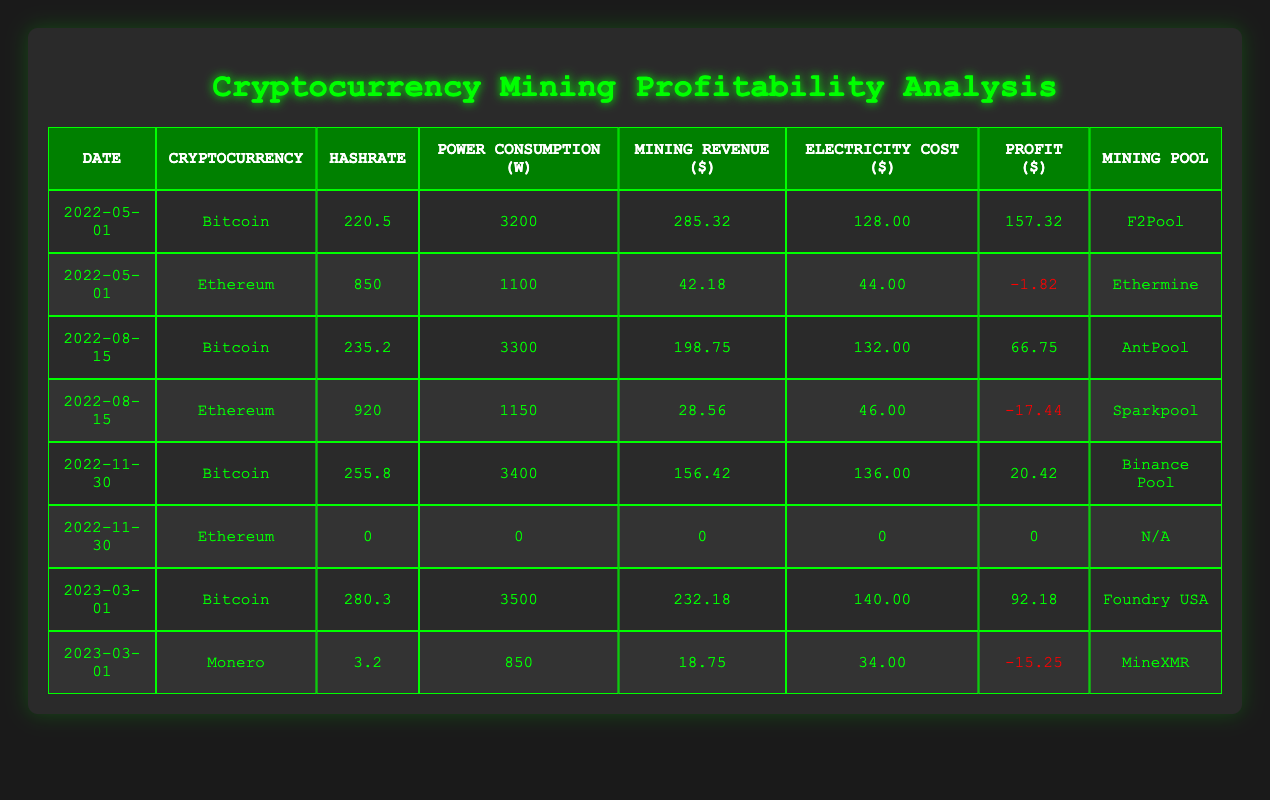What is the profit for Bitcoin on May 1, 2022? The profit for Bitcoin on May 1, 2022, is located directly in the table under the profit column in the corresponding row. It shows a profit of 157.32.
Answer: 157.32 What was the electricity cost for mining Ethereum on August 15, 2022? To find the electricity cost of Ethereum on August 15, 2022, check the row for Ethereum on that date, where the electricity cost is specified as 46.00.
Answer: 46.00 Which cryptocurrency had the highest profit on March 1, 2023? To determine the highest profit on March 1, 2023, compare the profit values from the table for all cryptocurrencies listed on that date. Bitcoin has a profit of 92.18, while Monero has a profit of -15.25. Bitcoin has the highest profit.
Answer: Bitcoin What is the average mining revenue for Bitcoin across all the recorded dates? First, gather the mining revenue values for Bitcoin from each row: 285.32, 198.75, 156.42, and 232.18. Next, add these values together: 285.32 + 198.75 + 156.42 + 232.18 = 872.67. Then divide by the total number of records for Bitcoin, which is 4: 872.67 / 4 = 218.17.
Answer: 218.17 Did Ethereum have a profit on November 30, 2022? By looking at the row for Ethereum on November 30, 2022, we see that the profit for this entry is 0, which means there was neither a profit nor a loss. Therefore, it can be concluded that Ethereum did not have a profit on this date.
Answer: No What was the total electricity cost for Bitcoin mining across all recorded dates? The electricity costs for Bitcoin are: 128.00 (May 1), 132.00 (August 15), 136.00 (November 30), and 140.00 (March 1). By adding these values, we find: 128.00 + 132.00 + 136.00 + 140.00 = 536.00, which is the total electricity cost for Bitcoin mining.
Answer: 536.00 Which mining pool yielded the least profit for Ethereum on August 15, 2022? The profit for Ethereum on August 15, 2022, is -17.44, which is lower than any other value in the profit column for Ethereum. The corresponding mining pool for this date is Sparkpool. Therefore, Sparkpool yielded the least profit for Ethereum on this date.
Answer: Sparkpool What was the hashrate for Monero on March 1, 2023? To find the hashrate for Monero on March 1, 2023, check the row corresponding to Monero for that date. The hashrate is listed as 3.2.
Answer: 3.2 